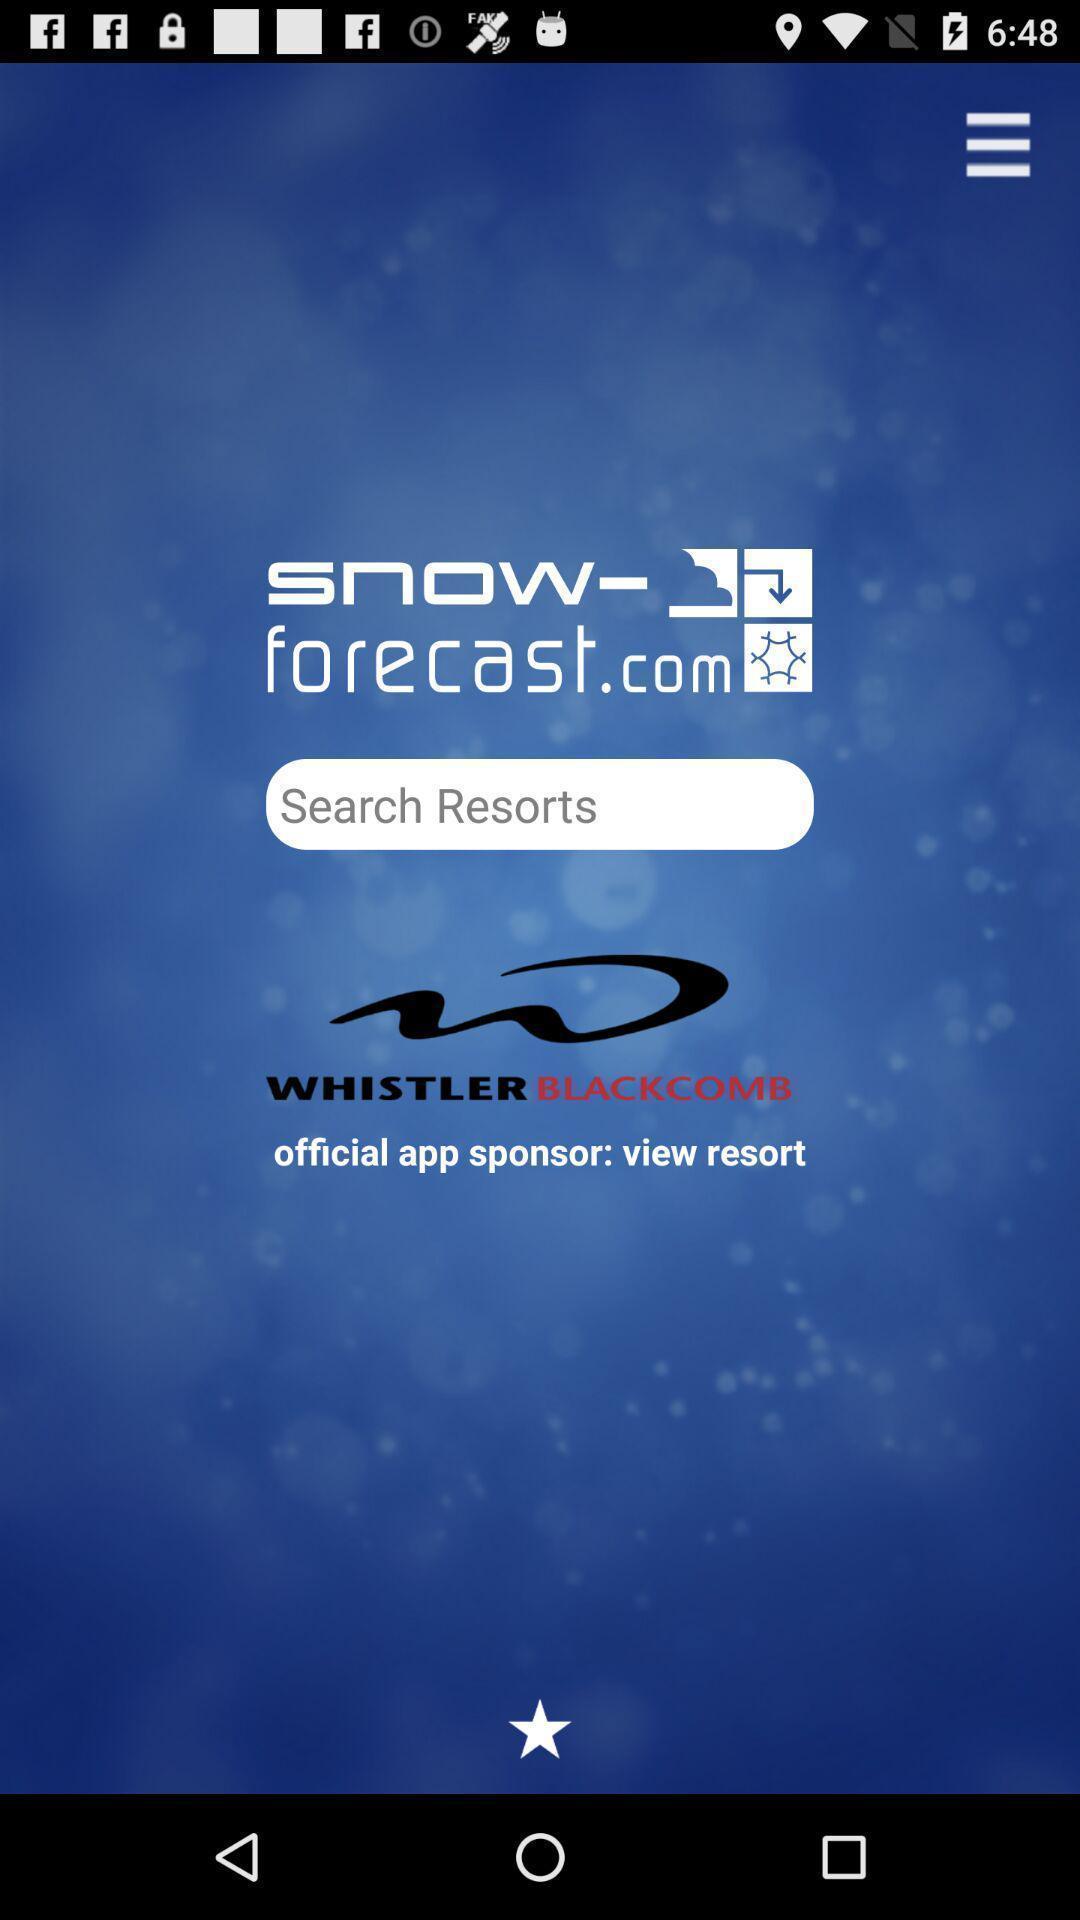Please provide a description for this image. Welcome page for a resorts searching app. 